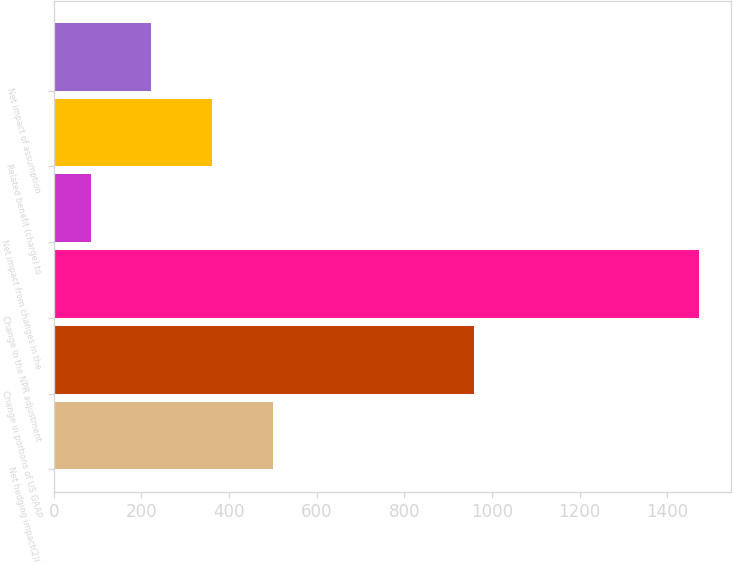<chart> <loc_0><loc_0><loc_500><loc_500><bar_chart><fcel>Net hedging impact(2)(3)<fcel>Change in portions of US GAAP<fcel>Change in the NPR adjustment<fcel>Net impact from changes in the<fcel>Related benefit (charge) to<fcel>Net impact of assumption<nl><fcel>500.4<fcel>959<fcel>1472<fcel>84<fcel>361.6<fcel>222.8<nl></chart> 